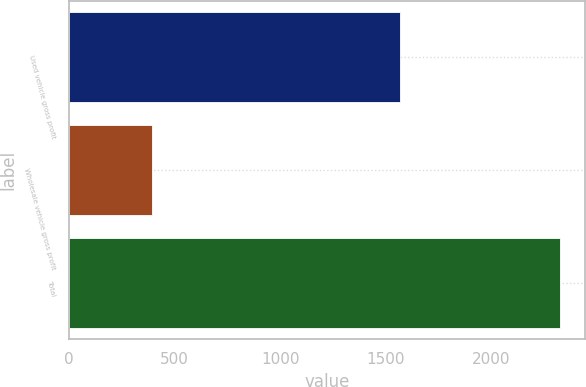Convert chart. <chart><loc_0><loc_0><loc_500><loc_500><bar_chart><fcel>Used vehicle gross profit<fcel>Wholesale vehicle gross profit<fcel>Total<nl><fcel>1567.6<fcel>392.5<fcel>2328.9<nl></chart> 